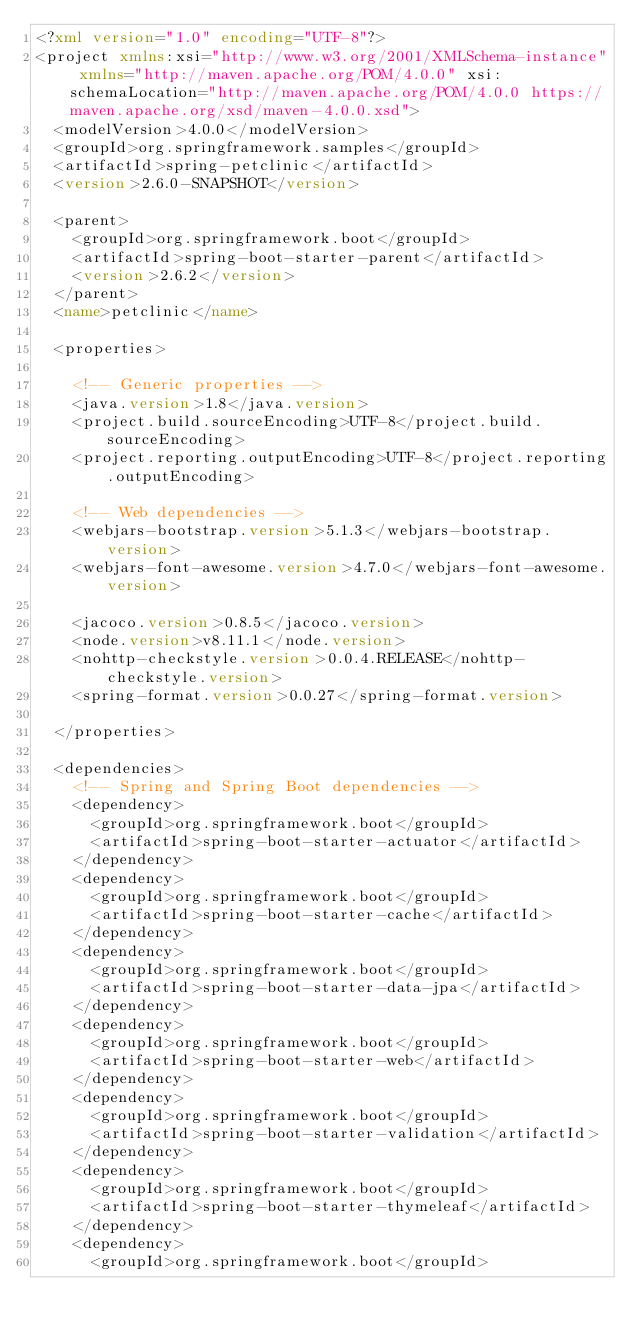<code> <loc_0><loc_0><loc_500><loc_500><_XML_><?xml version="1.0" encoding="UTF-8"?>
<project xmlns:xsi="http://www.w3.org/2001/XMLSchema-instance" xmlns="http://maven.apache.org/POM/4.0.0" xsi:schemaLocation="http://maven.apache.org/POM/4.0.0 https://maven.apache.org/xsd/maven-4.0.0.xsd">
  <modelVersion>4.0.0</modelVersion>
  <groupId>org.springframework.samples</groupId>
  <artifactId>spring-petclinic</artifactId>
  <version>2.6.0-SNAPSHOT</version>

  <parent>
    <groupId>org.springframework.boot</groupId>
    <artifactId>spring-boot-starter-parent</artifactId>
    <version>2.6.2</version>
  </parent>
  <name>petclinic</name>

  <properties>

    <!-- Generic properties -->
    <java.version>1.8</java.version>
    <project.build.sourceEncoding>UTF-8</project.build.sourceEncoding>
    <project.reporting.outputEncoding>UTF-8</project.reporting.outputEncoding>

    <!-- Web dependencies -->
    <webjars-bootstrap.version>5.1.3</webjars-bootstrap.version>
    <webjars-font-awesome.version>4.7.0</webjars-font-awesome.version>

    <jacoco.version>0.8.5</jacoco.version>
    <node.version>v8.11.1</node.version>
    <nohttp-checkstyle.version>0.0.4.RELEASE</nohttp-checkstyle.version>
    <spring-format.version>0.0.27</spring-format.version>

  </properties>

  <dependencies>
    <!-- Spring and Spring Boot dependencies -->
    <dependency>
      <groupId>org.springframework.boot</groupId>
      <artifactId>spring-boot-starter-actuator</artifactId>
    </dependency>
    <dependency>
      <groupId>org.springframework.boot</groupId>
      <artifactId>spring-boot-starter-cache</artifactId>
    </dependency>
    <dependency>
      <groupId>org.springframework.boot</groupId>
      <artifactId>spring-boot-starter-data-jpa</artifactId>
    </dependency>
    <dependency>
      <groupId>org.springframework.boot</groupId>
      <artifactId>spring-boot-starter-web</artifactId>
    </dependency>
    <dependency>
      <groupId>org.springframework.boot</groupId>
      <artifactId>spring-boot-starter-validation</artifactId>
    </dependency>
    <dependency>
      <groupId>org.springframework.boot</groupId>
      <artifactId>spring-boot-starter-thymeleaf</artifactId>
    </dependency>
    <dependency>
      <groupId>org.springframework.boot</groupId></code> 